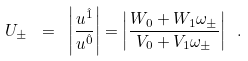<formula> <loc_0><loc_0><loc_500><loc_500>U _ { \pm } \ = \ \left | \frac { u ^ { \hat { 1 } } } { u ^ { \hat { 0 } } } \right | = \left | \frac { W _ { 0 } + W _ { 1 } \omega _ { \pm } } { V _ { 0 } + V _ { 1 } \omega _ { \pm } } \right | \ .</formula> 